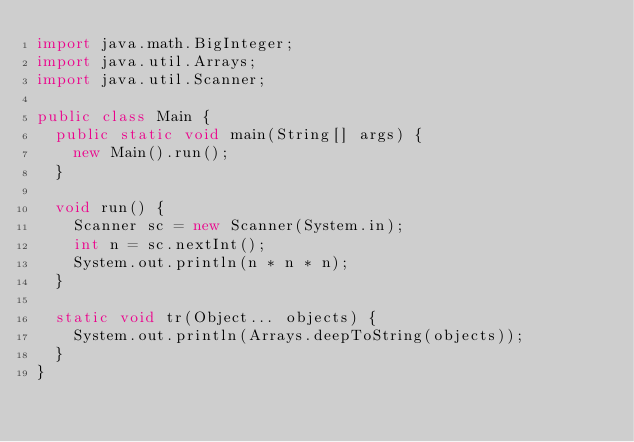<code> <loc_0><loc_0><loc_500><loc_500><_Java_>import java.math.BigInteger;
import java.util.Arrays;
import java.util.Scanner;

public class Main {
	public static void main(String[] args) {
		new Main().run();
	}

	void run() {
		Scanner sc = new Scanner(System.in);
		int n = sc.nextInt();
		System.out.println(n * n * n);
	}

	static void tr(Object... objects) {
		System.out.println(Arrays.deepToString(objects));
	}
}
</code> 